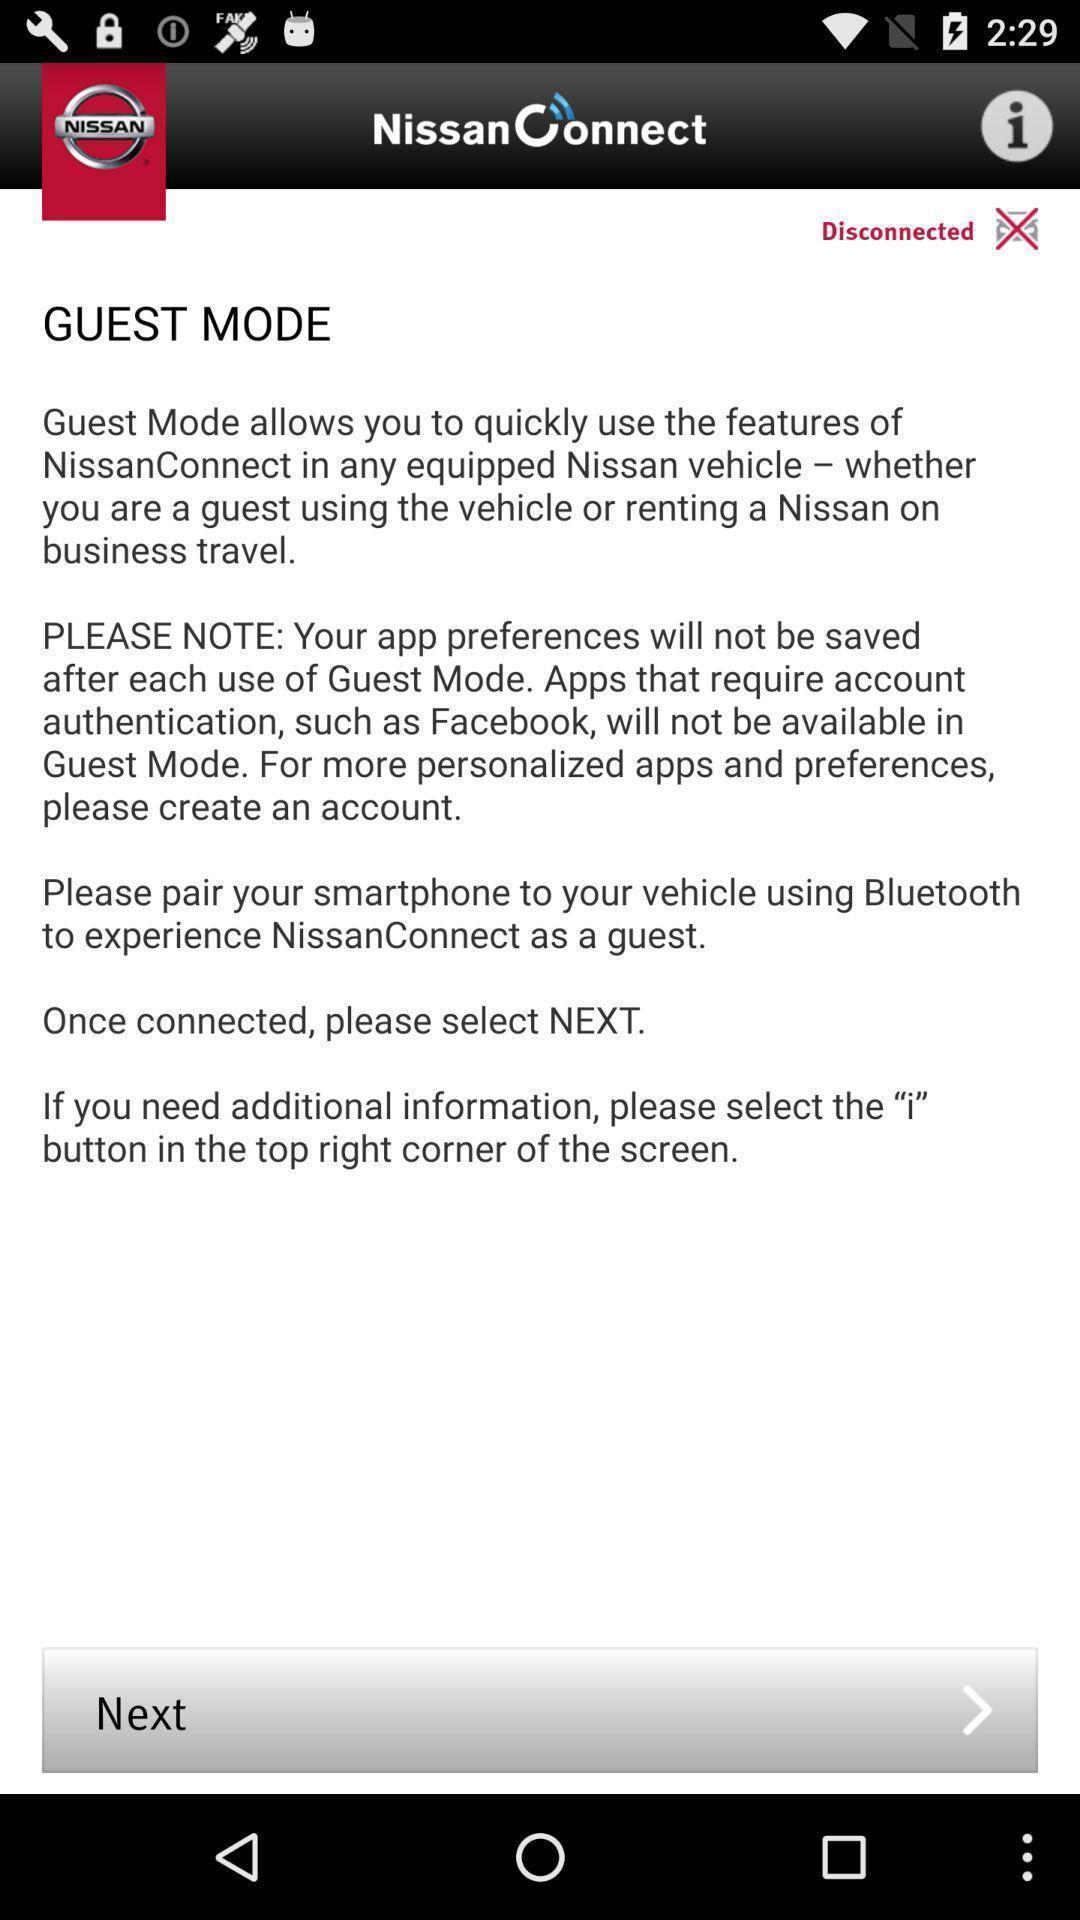Provide a detailed account of this screenshot. Screen displaying the information about guest mode. 